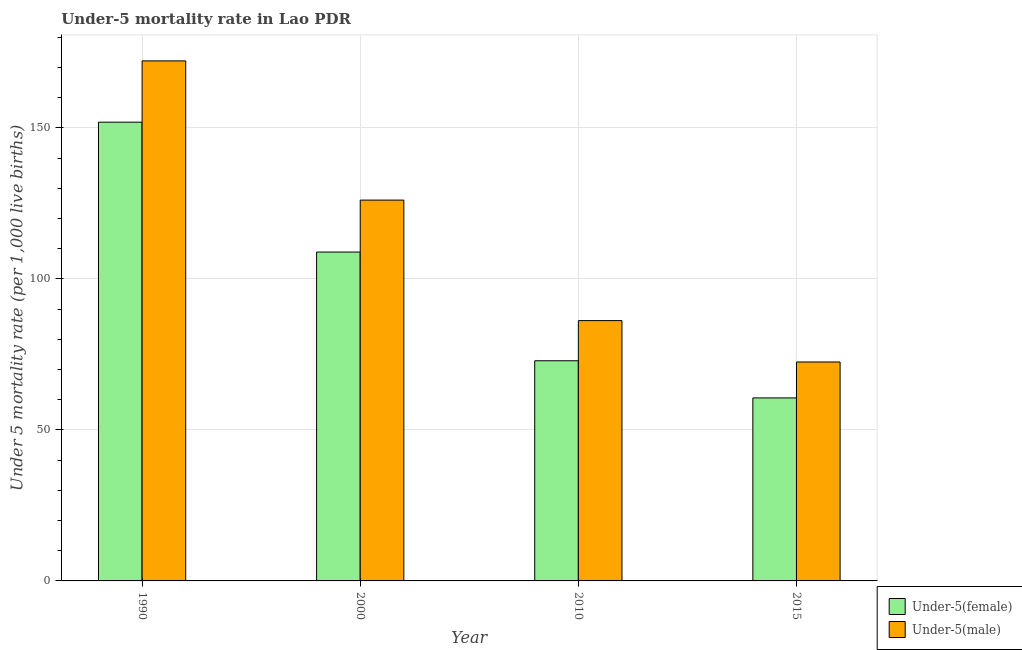How many different coloured bars are there?
Ensure brevity in your answer.  2. How many groups of bars are there?
Make the answer very short. 4. Are the number of bars per tick equal to the number of legend labels?
Your answer should be compact. Yes. Are the number of bars on each tick of the X-axis equal?
Offer a very short reply. Yes. How many bars are there on the 4th tick from the left?
Offer a very short reply. 2. How many bars are there on the 1st tick from the right?
Give a very brief answer. 2. What is the label of the 4th group of bars from the left?
Keep it short and to the point. 2015. What is the under-5 female mortality rate in 2010?
Your answer should be very brief. 72.9. Across all years, what is the maximum under-5 male mortality rate?
Keep it short and to the point. 172.2. Across all years, what is the minimum under-5 male mortality rate?
Your response must be concise. 72.5. In which year was the under-5 female mortality rate minimum?
Offer a terse response. 2015. What is the total under-5 female mortality rate in the graph?
Your answer should be very brief. 394.3. What is the difference between the under-5 female mortality rate in 2010 and that in 2015?
Ensure brevity in your answer.  12.3. What is the difference between the under-5 male mortality rate in 1990 and the under-5 female mortality rate in 2000?
Give a very brief answer. 46.1. What is the average under-5 male mortality rate per year?
Your response must be concise. 114.25. In the year 2000, what is the difference between the under-5 male mortality rate and under-5 female mortality rate?
Offer a very short reply. 0. In how many years, is the under-5 male mortality rate greater than 50?
Give a very brief answer. 4. What is the ratio of the under-5 female mortality rate in 2000 to that in 2010?
Give a very brief answer. 1.49. Is the under-5 female mortality rate in 1990 less than that in 2000?
Ensure brevity in your answer.  No. Is the difference between the under-5 male mortality rate in 1990 and 2015 greater than the difference between the under-5 female mortality rate in 1990 and 2015?
Your answer should be very brief. No. What is the difference between the highest and the lowest under-5 male mortality rate?
Give a very brief answer. 99.7. Is the sum of the under-5 female mortality rate in 2000 and 2015 greater than the maximum under-5 male mortality rate across all years?
Keep it short and to the point. Yes. What does the 2nd bar from the left in 2010 represents?
Make the answer very short. Under-5(male). What does the 1st bar from the right in 2015 represents?
Provide a short and direct response. Under-5(male). Are all the bars in the graph horizontal?
Keep it short and to the point. No. How many years are there in the graph?
Keep it short and to the point. 4. Does the graph contain any zero values?
Make the answer very short. No. How many legend labels are there?
Provide a succinct answer. 2. How are the legend labels stacked?
Your answer should be compact. Vertical. What is the title of the graph?
Your response must be concise. Under-5 mortality rate in Lao PDR. What is the label or title of the Y-axis?
Offer a very short reply. Under 5 mortality rate (per 1,0 live births). What is the Under 5 mortality rate (per 1,000 live births) in Under-5(female) in 1990?
Offer a terse response. 151.9. What is the Under 5 mortality rate (per 1,000 live births) in Under-5(male) in 1990?
Provide a succinct answer. 172.2. What is the Under 5 mortality rate (per 1,000 live births) of Under-5(female) in 2000?
Ensure brevity in your answer.  108.9. What is the Under 5 mortality rate (per 1,000 live births) in Under-5(male) in 2000?
Provide a short and direct response. 126.1. What is the Under 5 mortality rate (per 1,000 live births) in Under-5(female) in 2010?
Your answer should be very brief. 72.9. What is the Under 5 mortality rate (per 1,000 live births) in Under-5(male) in 2010?
Make the answer very short. 86.2. What is the Under 5 mortality rate (per 1,000 live births) of Under-5(female) in 2015?
Your response must be concise. 60.6. What is the Under 5 mortality rate (per 1,000 live births) of Under-5(male) in 2015?
Make the answer very short. 72.5. Across all years, what is the maximum Under 5 mortality rate (per 1,000 live births) in Under-5(female)?
Offer a very short reply. 151.9. Across all years, what is the maximum Under 5 mortality rate (per 1,000 live births) of Under-5(male)?
Ensure brevity in your answer.  172.2. Across all years, what is the minimum Under 5 mortality rate (per 1,000 live births) of Under-5(female)?
Your answer should be very brief. 60.6. Across all years, what is the minimum Under 5 mortality rate (per 1,000 live births) in Under-5(male)?
Provide a succinct answer. 72.5. What is the total Under 5 mortality rate (per 1,000 live births) in Under-5(female) in the graph?
Provide a short and direct response. 394.3. What is the total Under 5 mortality rate (per 1,000 live births) in Under-5(male) in the graph?
Your answer should be very brief. 457. What is the difference between the Under 5 mortality rate (per 1,000 live births) in Under-5(male) in 1990 and that in 2000?
Offer a terse response. 46.1. What is the difference between the Under 5 mortality rate (per 1,000 live births) of Under-5(female) in 1990 and that in 2010?
Your answer should be compact. 79. What is the difference between the Under 5 mortality rate (per 1,000 live births) of Under-5(female) in 1990 and that in 2015?
Ensure brevity in your answer.  91.3. What is the difference between the Under 5 mortality rate (per 1,000 live births) in Under-5(male) in 1990 and that in 2015?
Your answer should be compact. 99.7. What is the difference between the Under 5 mortality rate (per 1,000 live births) of Under-5(male) in 2000 and that in 2010?
Provide a short and direct response. 39.9. What is the difference between the Under 5 mortality rate (per 1,000 live births) of Under-5(female) in 2000 and that in 2015?
Provide a succinct answer. 48.3. What is the difference between the Under 5 mortality rate (per 1,000 live births) in Under-5(male) in 2000 and that in 2015?
Ensure brevity in your answer.  53.6. What is the difference between the Under 5 mortality rate (per 1,000 live births) of Under-5(female) in 2010 and that in 2015?
Provide a short and direct response. 12.3. What is the difference between the Under 5 mortality rate (per 1,000 live births) in Under-5(female) in 1990 and the Under 5 mortality rate (per 1,000 live births) in Under-5(male) in 2000?
Offer a terse response. 25.8. What is the difference between the Under 5 mortality rate (per 1,000 live births) of Under-5(female) in 1990 and the Under 5 mortality rate (per 1,000 live births) of Under-5(male) in 2010?
Make the answer very short. 65.7. What is the difference between the Under 5 mortality rate (per 1,000 live births) of Under-5(female) in 1990 and the Under 5 mortality rate (per 1,000 live births) of Under-5(male) in 2015?
Provide a short and direct response. 79.4. What is the difference between the Under 5 mortality rate (per 1,000 live births) of Under-5(female) in 2000 and the Under 5 mortality rate (per 1,000 live births) of Under-5(male) in 2010?
Give a very brief answer. 22.7. What is the difference between the Under 5 mortality rate (per 1,000 live births) of Under-5(female) in 2000 and the Under 5 mortality rate (per 1,000 live births) of Under-5(male) in 2015?
Offer a terse response. 36.4. What is the average Under 5 mortality rate (per 1,000 live births) of Under-5(female) per year?
Provide a short and direct response. 98.58. What is the average Under 5 mortality rate (per 1,000 live births) of Under-5(male) per year?
Your answer should be compact. 114.25. In the year 1990, what is the difference between the Under 5 mortality rate (per 1,000 live births) of Under-5(female) and Under 5 mortality rate (per 1,000 live births) of Under-5(male)?
Your answer should be very brief. -20.3. In the year 2000, what is the difference between the Under 5 mortality rate (per 1,000 live births) of Under-5(female) and Under 5 mortality rate (per 1,000 live births) of Under-5(male)?
Your answer should be compact. -17.2. What is the ratio of the Under 5 mortality rate (per 1,000 live births) of Under-5(female) in 1990 to that in 2000?
Provide a short and direct response. 1.39. What is the ratio of the Under 5 mortality rate (per 1,000 live births) of Under-5(male) in 1990 to that in 2000?
Ensure brevity in your answer.  1.37. What is the ratio of the Under 5 mortality rate (per 1,000 live births) of Under-5(female) in 1990 to that in 2010?
Keep it short and to the point. 2.08. What is the ratio of the Under 5 mortality rate (per 1,000 live births) of Under-5(male) in 1990 to that in 2010?
Your response must be concise. 2. What is the ratio of the Under 5 mortality rate (per 1,000 live births) in Under-5(female) in 1990 to that in 2015?
Keep it short and to the point. 2.51. What is the ratio of the Under 5 mortality rate (per 1,000 live births) of Under-5(male) in 1990 to that in 2015?
Offer a very short reply. 2.38. What is the ratio of the Under 5 mortality rate (per 1,000 live births) in Under-5(female) in 2000 to that in 2010?
Give a very brief answer. 1.49. What is the ratio of the Under 5 mortality rate (per 1,000 live births) in Under-5(male) in 2000 to that in 2010?
Your answer should be very brief. 1.46. What is the ratio of the Under 5 mortality rate (per 1,000 live births) in Under-5(female) in 2000 to that in 2015?
Give a very brief answer. 1.8. What is the ratio of the Under 5 mortality rate (per 1,000 live births) of Under-5(male) in 2000 to that in 2015?
Give a very brief answer. 1.74. What is the ratio of the Under 5 mortality rate (per 1,000 live births) in Under-5(female) in 2010 to that in 2015?
Provide a succinct answer. 1.2. What is the ratio of the Under 5 mortality rate (per 1,000 live births) of Under-5(male) in 2010 to that in 2015?
Your answer should be very brief. 1.19. What is the difference between the highest and the second highest Under 5 mortality rate (per 1,000 live births) in Under-5(male)?
Your answer should be compact. 46.1. What is the difference between the highest and the lowest Under 5 mortality rate (per 1,000 live births) in Under-5(female)?
Make the answer very short. 91.3. What is the difference between the highest and the lowest Under 5 mortality rate (per 1,000 live births) in Under-5(male)?
Your response must be concise. 99.7. 